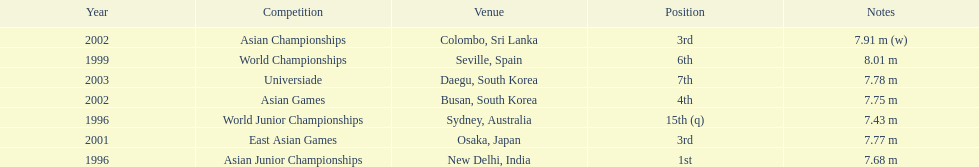Which competition did this person compete in immediately before the east asian games in 2001? World Championships. 